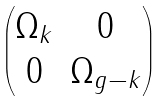Convert formula to latex. <formula><loc_0><loc_0><loc_500><loc_500>\begin{pmatrix} \Omega _ { k } & 0 \\ 0 & \Omega _ { g - k } \end{pmatrix}</formula> 